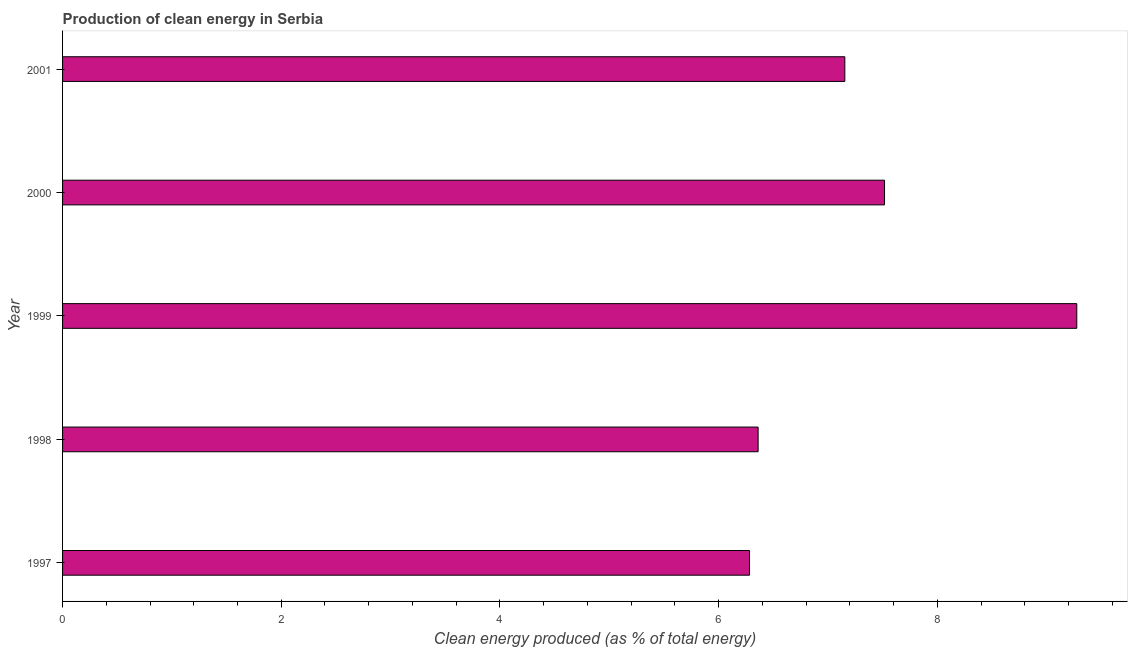Does the graph contain any zero values?
Offer a terse response. No. What is the title of the graph?
Give a very brief answer. Production of clean energy in Serbia. What is the label or title of the X-axis?
Your response must be concise. Clean energy produced (as % of total energy). What is the production of clean energy in 2000?
Offer a very short reply. 7.52. Across all years, what is the maximum production of clean energy?
Keep it short and to the point. 9.28. Across all years, what is the minimum production of clean energy?
Your answer should be compact. 6.28. In which year was the production of clean energy maximum?
Keep it short and to the point. 1999. In which year was the production of clean energy minimum?
Make the answer very short. 1997. What is the sum of the production of clean energy?
Make the answer very short. 36.59. What is the difference between the production of clean energy in 1999 and 2000?
Provide a short and direct response. 1.76. What is the average production of clean energy per year?
Your response must be concise. 7.32. What is the median production of clean energy?
Your response must be concise. 7.15. In how many years, is the production of clean energy greater than 3.6 %?
Offer a terse response. 5. Do a majority of the years between 2000 and 2001 (inclusive) have production of clean energy greater than 4.8 %?
Your response must be concise. Yes. What is the ratio of the production of clean energy in 1999 to that in 2000?
Your response must be concise. 1.23. Is the production of clean energy in 1997 less than that in 2000?
Give a very brief answer. Yes. Is the difference between the production of clean energy in 2000 and 2001 greater than the difference between any two years?
Make the answer very short. No. What is the difference between the highest and the second highest production of clean energy?
Ensure brevity in your answer.  1.76. Is the sum of the production of clean energy in 1999 and 2000 greater than the maximum production of clean energy across all years?
Provide a succinct answer. Yes. What is the difference between the highest and the lowest production of clean energy?
Ensure brevity in your answer.  2.99. In how many years, is the production of clean energy greater than the average production of clean energy taken over all years?
Provide a short and direct response. 2. Are all the bars in the graph horizontal?
Offer a terse response. Yes. How many years are there in the graph?
Offer a very short reply. 5. Are the values on the major ticks of X-axis written in scientific E-notation?
Your answer should be very brief. No. What is the Clean energy produced (as % of total energy) of 1997?
Give a very brief answer. 6.28. What is the Clean energy produced (as % of total energy) of 1998?
Make the answer very short. 6.36. What is the Clean energy produced (as % of total energy) of 1999?
Provide a succinct answer. 9.28. What is the Clean energy produced (as % of total energy) of 2000?
Your answer should be very brief. 7.52. What is the Clean energy produced (as % of total energy) in 2001?
Provide a short and direct response. 7.15. What is the difference between the Clean energy produced (as % of total energy) in 1997 and 1998?
Your response must be concise. -0.08. What is the difference between the Clean energy produced (as % of total energy) in 1997 and 1999?
Ensure brevity in your answer.  -2.99. What is the difference between the Clean energy produced (as % of total energy) in 1997 and 2000?
Give a very brief answer. -1.23. What is the difference between the Clean energy produced (as % of total energy) in 1997 and 2001?
Your answer should be compact. -0.87. What is the difference between the Clean energy produced (as % of total energy) in 1998 and 1999?
Keep it short and to the point. -2.91. What is the difference between the Clean energy produced (as % of total energy) in 1998 and 2000?
Ensure brevity in your answer.  -1.16. What is the difference between the Clean energy produced (as % of total energy) in 1998 and 2001?
Provide a succinct answer. -0.79. What is the difference between the Clean energy produced (as % of total energy) in 1999 and 2000?
Offer a terse response. 1.76. What is the difference between the Clean energy produced (as % of total energy) in 1999 and 2001?
Your answer should be very brief. 2.12. What is the difference between the Clean energy produced (as % of total energy) in 2000 and 2001?
Offer a very short reply. 0.36. What is the ratio of the Clean energy produced (as % of total energy) in 1997 to that in 1998?
Make the answer very short. 0.99. What is the ratio of the Clean energy produced (as % of total energy) in 1997 to that in 1999?
Give a very brief answer. 0.68. What is the ratio of the Clean energy produced (as % of total energy) in 1997 to that in 2000?
Provide a short and direct response. 0.84. What is the ratio of the Clean energy produced (as % of total energy) in 1997 to that in 2001?
Your response must be concise. 0.88. What is the ratio of the Clean energy produced (as % of total energy) in 1998 to that in 1999?
Your answer should be very brief. 0.69. What is the ratio of the Clean energy produced (as % of total energy) in 1998 to that in 2000?
Provide a short and direct response. 0.85. What is the ratio of the Clean energy produced (as % of total energy) in 1998 to that in 2001?
Provide a succinct answer. 0.89. What is the ratio of the Clean energy produced (as % of total energy) in 1999 to that in 2000?
Make the answer very short. 1.23. What is the ratio of the Clean energy produced (as % of total energy) in 1999 to that in 2001?
Offer a terse response. 1.3. What is the ratio of the Clean energy produced (as % of total energy) in 2000 to that in 2001?
Your answer should be compact. 1.05. 